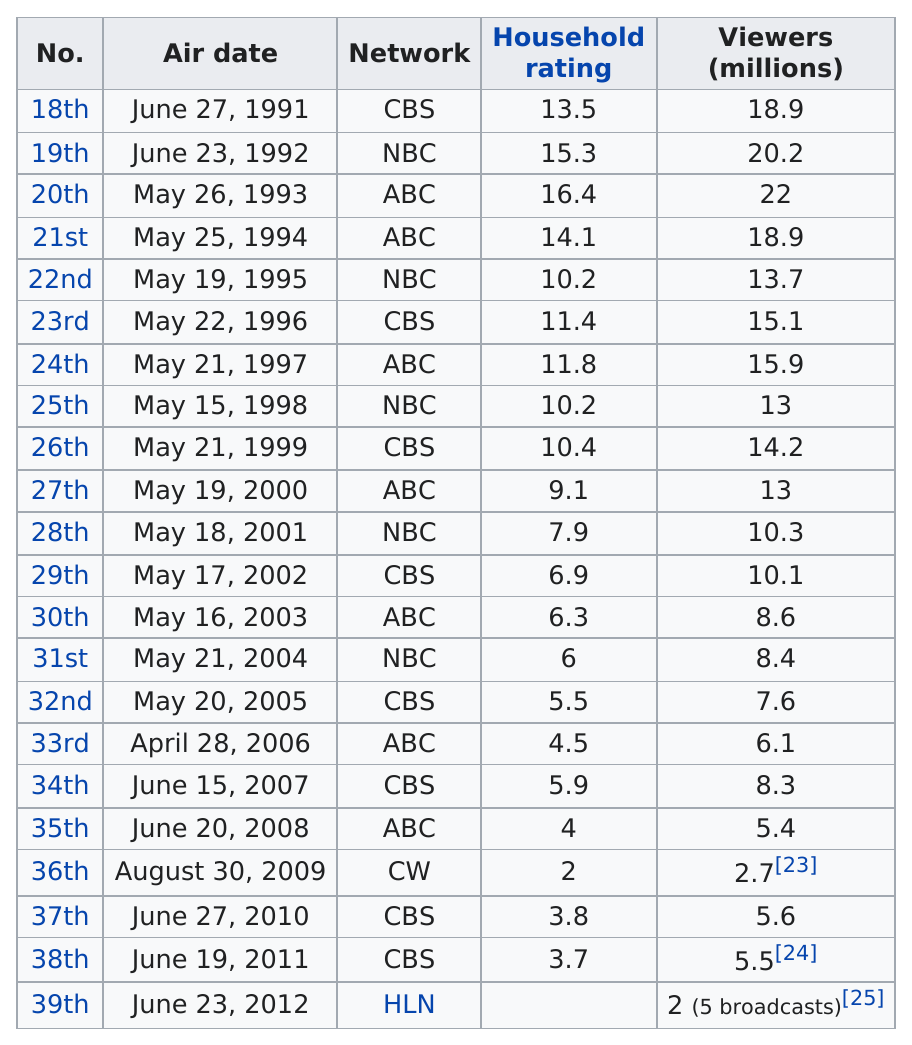Point out several critical features in this image. The ceremony that had the same number of viewers as the 18th and 21st ceremonies was the same. ABC was the network that had the all-time top number of viewers. CBS is the network that has the most airings. The highest rated year before 2000 was 1993. After 18.9, the network with the next highest number of viewers was ABC. 